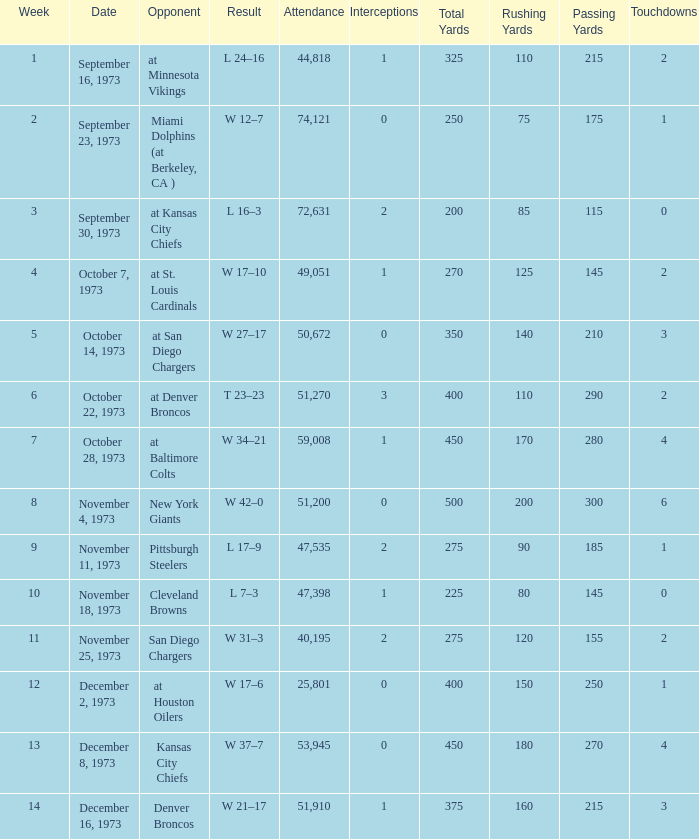Parse the table in full. {'header': ['Week', 'Date', 'Opponent', 'Result', 'Attendance', 'Interceptions', 'Total Yards', 'Rushing Yards', 'Passing Yards', 'Touchdowns'], 'rows': [['1', 'September 16, 1973', 'at Minnesota Vikings', 'L 24–16', '44,818', '1', '325', '110', '215', '2'], ['2', 'September 23, 1973', 'Miami Dolphins (at Berkeley, CA )', 'W 12–7', '74,121', '0', '250', '75', '175', '1'], ['3', 'September 30, 1973', 'at Kansas City Chiefs', 'L 16–3', '72,631', '2', '200', '85', '115', '0'], ['4', 'October 7, 1973', 'at St. Louis Cardinals', 'W 17–10', '49,051', '1', '270', '125', '145', '2'], ['5', 'October 14, 1973', 'at San Diego Chargers', 'W 27–17', '50,672', '0', '350', '140', '210', '3'], ['6', 'October 22, 1973', 'at Denver Broncos', 'T 23–23', '51,270', '3', '400', '110', '290', '2'], ['7', 'October 28, 1973', 'at Baltimore Colts', 'W 34–21', '59,008', '1', '450', '170', '280', '4'], ['8', 'November 4, 1973', 'New York Giants', 'W 42–0', '51,200', '0', '500', '200', '300', '6'], ['9', 'November 11, 1973', 'Pittsburgh Steelers', 'L 17–9', '47,535', '2', '275', '90', '185', '1'], ['10', 'November 18, 1973', 'Cleveland Browns', 'L 7–3', '47,398', '1', '225', '80', '145', '0'], ['11', 'November 25, 1973', 'San Diego Chargers', 'W 31–3', '40,195', '2', '275', '120', '155', '2'], ['12', 'December 2, 1973', 'at Houston Oilers', 'W 17–6', '25,801', '0', '400', '150', '250', '1'], ['13', 'December 8, 1973', 'Kansas City Chiefs', 'W 37–7', '53,945', '0', '450', '180', '270', '4'], ['14', 'December 16, 1973', 'Denver Broncos', 'W 21–17', '51,910', '1', '375', '160', '215', '3']]} What is the attendance for the game against the Kansas City Chiefs earlier than week 13? None. 